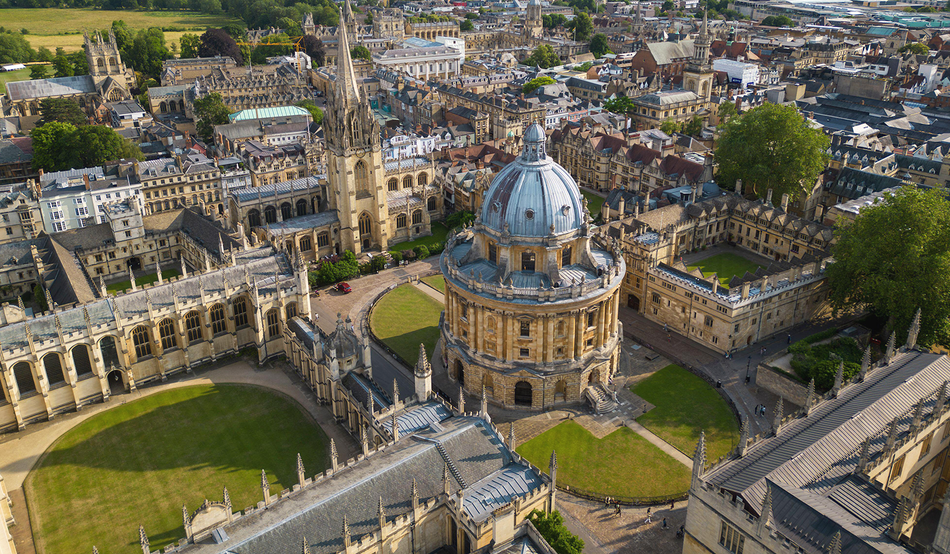What do you see happening in this image? The image captures an aerial view of the historic heart of Oxford University, showcasing the majestic Radcliffe Camera with its grand dome—a jewel in the crown of the city's scholarly legacy. Surrounding it, the university's colleges and buildings radiate outwards like a tapestry of intellectual pursuit, each structure resplendent with gothic spires and intricate stonework. The verdant quadrangles offer restful greenspaces within this esteemed bastion of learning, where students and academics have walked the halls for centuries. As we observe the harmony of architecture and landscape, the image invites us to contemplate the countless contributions to knowledge that have their roots in this storied institution. 